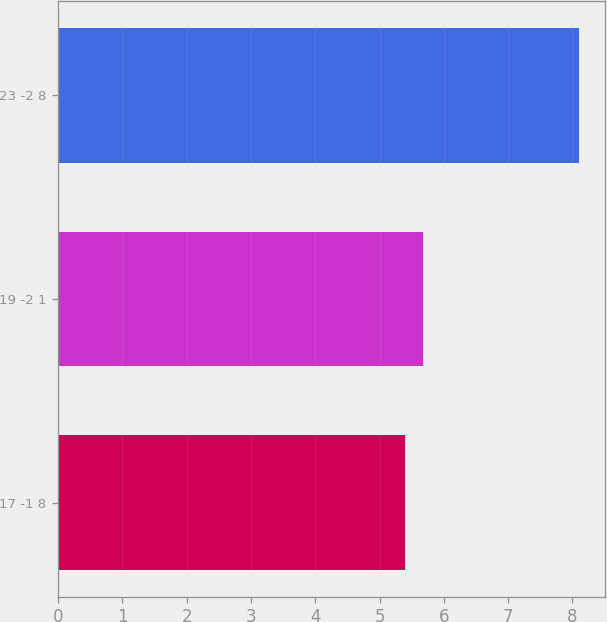Convert chart to OTSL. <chart><loc_0><loc_0><loc_500><loc_500><bar_chart><fcel>17 -1 8<fcel>19 -2 1<fcel>23 -2 8<nl><fcel>5.4<fcel>5.67<fcel>8.1<nl></chart> 